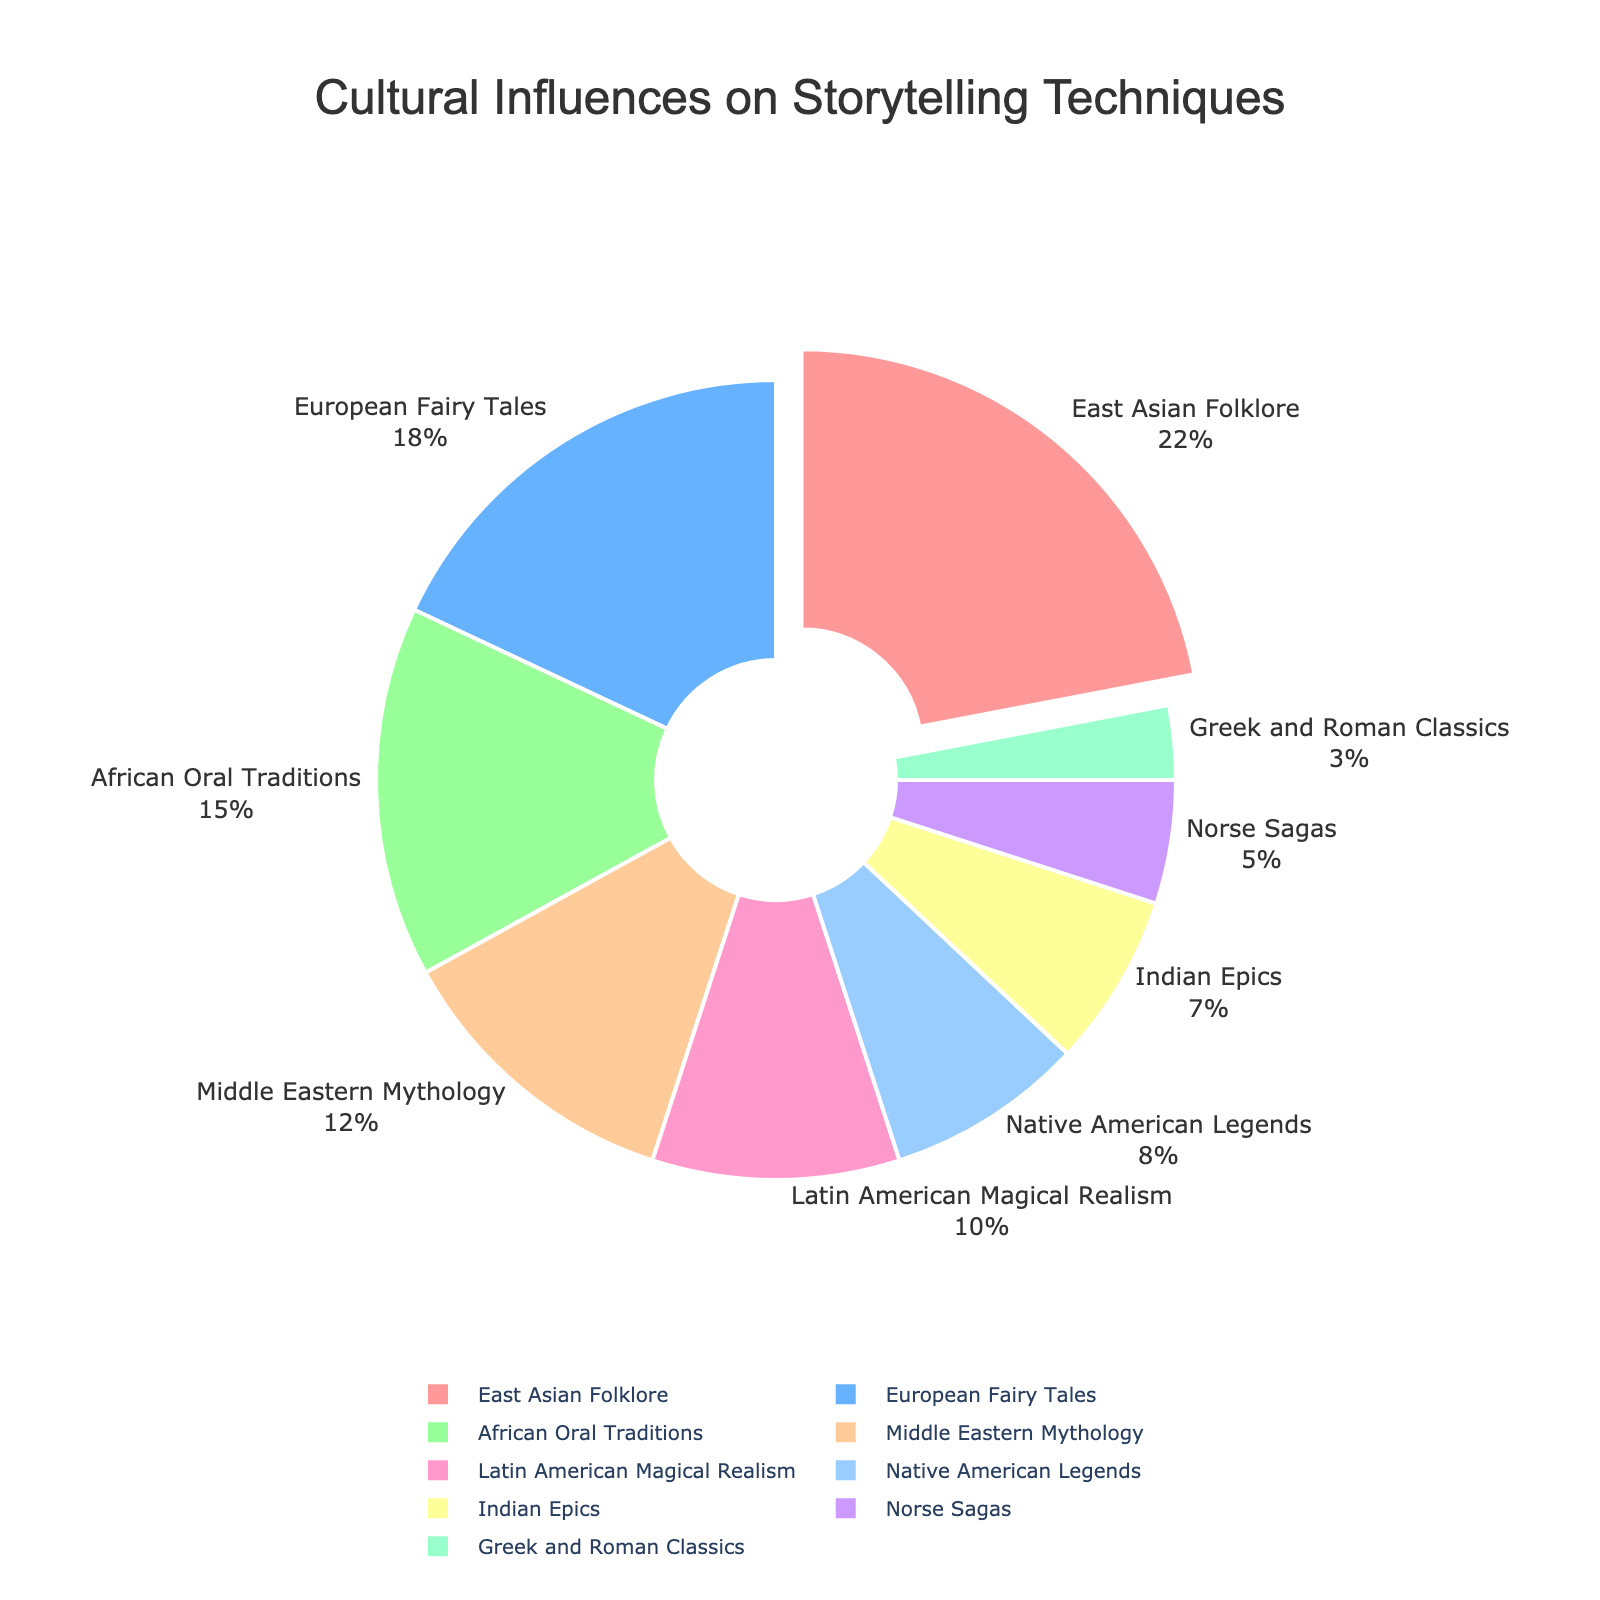Which cultural influence has the highest percentage? The pie chart shows that East Asian Folklore has the largest segment, highlighted in the chart by being slightly pulled out from the rest.
Answer: East Asian Folklore What is the combined percentage of African Oral Traditions and Middle Eastern Mythology? According to the pie chart, African Oral Traditions account for 15% and Middle Eastern Mythology for 12%. Adding these together gives: 15% + 12% = 27%.
Answer: 27% Which has a smaller representation: Latin American Magical Realism or Native American Legends? Observing the pie chart, Native American Legends covers 8% while Latin American Magical Realism covers 10%. Therefore, Native American Legends has a smaller representation.
Answer: Native American Legends By how much does European Fairy Tales' percentage exceed Indian Epics'? Referring to the pie chart, European Fairy Tales account for 18% and Indian Epics for 7%. The difference is calculated as: 18% - 7% = 11%.
Answer: 11% Identify the cultural influence segment with an area colored blue in the chart. The segment colored blue in the pie chart represents European Fairy Tales.
Answer: European Fairy Tales What is the percentage difference between the cultural influences with the highest and lowest representation? From the pie chart, East Asian Folklore has the highest percentage at 22% and Greek and Roman Classics the lowest at 3%. The difference is: 22% - 3% = 19%.
Answer: 19% Which cultural influence has a lower representation: Norse Sagas or Indian Epics? Reviewing the pie chart, Norse Sagas represent 5%, and Indian Epics represent 7%. Therefore, Norse Sagas have a lower representation.
Answer: Norse Sagas What total percentage do Native American Legends, Indian Epics, and African Oral Traditions collectively represent? Adding up the percentages shown in the pie chart: Native American Legends (8%), Indian Epics (7%), and African Oral Traditions (15%). The total is: 8% + 7% + 15% = 30%.
Answer: 30% Which two cultural influences have the closest percentage values? Observing the pie chart, Native American Legends (8%) and Indian Epics (7%) have the closest percentage values.
Answer: Native American Legends, Indian Epics 